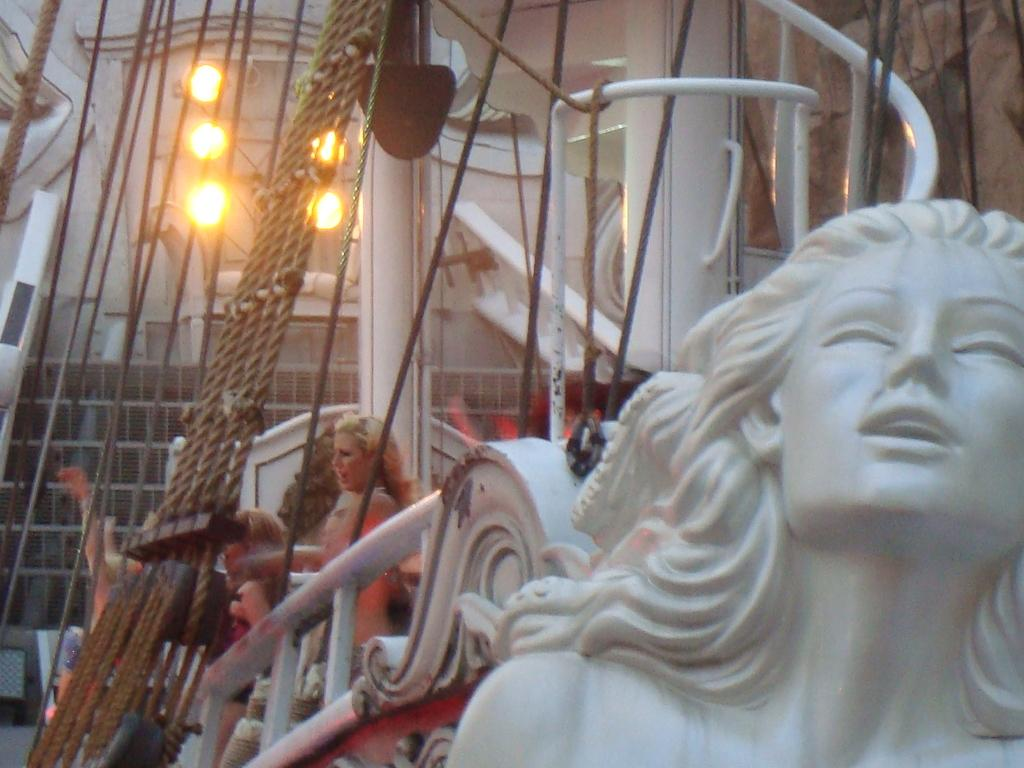What is the main subject in the front of the image? There is a statue in the front of the image. What else can be seen in the middle of the image? There are two persons standing in the middle of the image. What objects are on the left side of the image? There are ropes on the left side of the image. What can be seen in the background of the image? There are lights visible in the background of the image. What type of tax is being discussed by the two persons in the image? There is no indication in the image that the two persons are discussing any type of tax. 